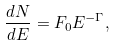Convert formula to latex. <formula><loc_0><loc_0><loc_500><loc_500>\frac { d N } { d E } = F _ { 0 } E ^ { - \Gamma } ,</formula> 